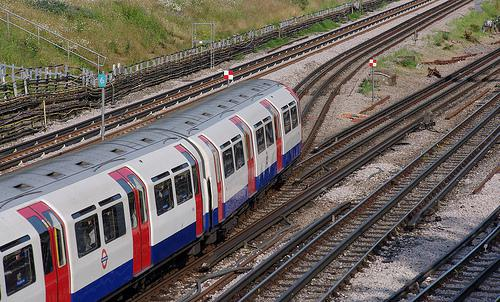Question: what is on the poles?
Choices:
A. Flags.
B. Stickers.
C. Artwork.
D. Red and white signs.
Answer with the letter. Answer: D 